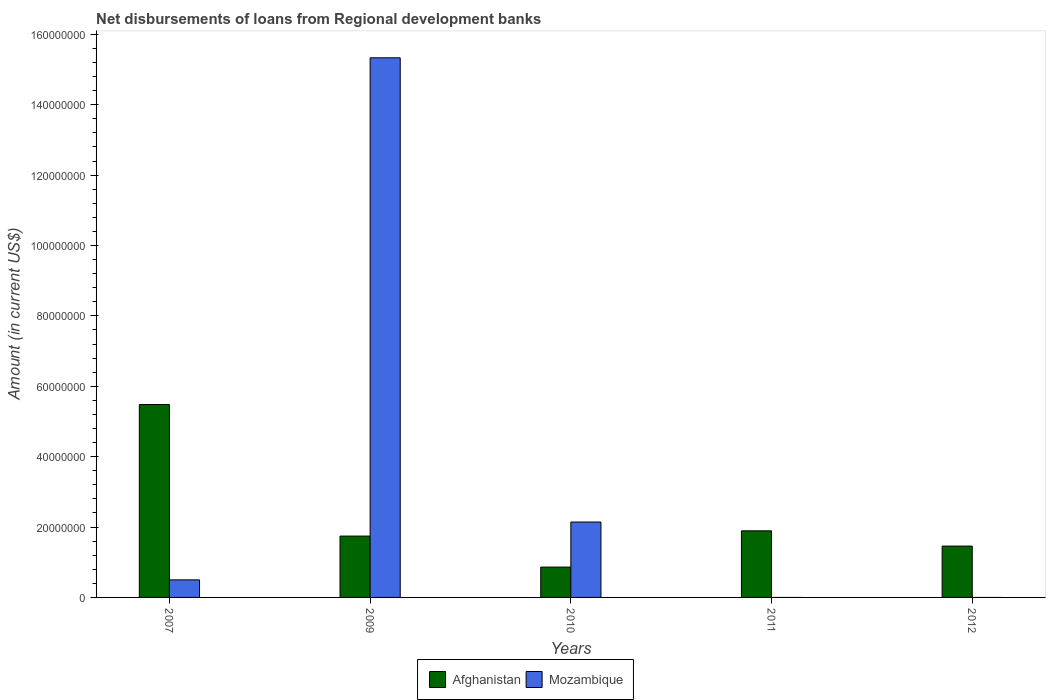How many bars are there on the 3rd tick from the left?
Provide a succinct answer. 2. In how many cases, is the number of bars for a given year not equal to the number of legend labels?
Your response must be concise. 2. What is the amount of disbursements of loans from regional development banks in Mozambique in 2010?
Provide a short and direct response. 2.14e+07. Across all years, what is the maximum amount of disbursements of loans from regional development banks in Mozambique?
Give a very brief answer. 1.53e+08. Across all years, what is the minimum amount of disbursements of loans from regional development banks in Afghanistan?
Keep it short and to the point. 8.62e+06. What is the total amount of disbursements of loans from regional development banks in Mozambique in the graph?
Ensure brevity in your answer.  1.80e+08. What is the difference between the amount of disbursements of loans from regional development banks in Afghanistan in 2007 and that in 2012?
Provide a short and direct response. 4.02e+07. What is the difference between the amount of disbursements of loans from regional development banks in Mozambique in 2011 and the amount of disbursements of loans from regional development banks in Afghanistan in 2012?
Offer a terse response. -1.46e+07. What is the average amount of disbursements of loans from regional development banks in Mozambique per year?
Ensure brevity in your answer.  3.59e+07. In the year 2009, what is the difference between the amount of disbursements of loans from regional development banks in Afghanistan and amount of disbursements of loans from regional development banks in Mozambique?
Offer a terse response. -1.36e+08. In how many years, is the amount of disbursements of loans from regional development banks in Afghanistan greater than 144000000 US$?
Your response must be concise. 0. What is the ratio of the amount of disbursements of loans from regional development banks in Mozambique in 2007 to that in 2010?
Offer a very short reply. 0.23. Is the amount of disbursements of loans from regional development banks in Afghanistan in 2007 less than that in 2011?
Offer a terse response. No. What is the difference between the highest and the second highest amount of disbursements of loans from regional development banks in Afghanistan?
Keep it short and to the point. 3.59e+07. What is the difference between the highest and the lowest amount of disbursements of loans from regional development banks in Afghanistan?
Your answer should be very brief. 4.62e+07. In how many years, is the amount of disbursements of loans from regional development banks in Afghanistan greater than the average amount of disbursements of loans from regional development banks in Afghanistan taken over all years?
Provide a succinct answer. 1. Are all the bars in the graph horizontal?
Your answer should be compact. No. What is the difference between two consecutive major ticks on the Y-axis?
Your answer should be very brief. 2.00e+07. Are the values on the major ticks of Y-axis written in scientific E-notation?
Your answer should be very brief. No. Does the graph contain any zero values?
Offer a very short reply. Yes. Does the graph contain grids?
Provide a succinct answer. No. Where does the legend appear in the graph?
Provide a short and direct response. Bottom center. How many legend labels are there?
Ensure brevity in your answer.  2. How are the legend labels stacked?
Ensure brevity in your answer.  Horizontal. What is the title of the graph?
Provide a succinct answer. Net disbursements of loans from Regional development banks. What is the label or title of the Y-axis?
Your answer should be compact. Amount (in current US$). What is the Amount (in current US$) of Afghanistan in 2007?
Provide a short and direct response. 5.48e+07. What is the Amount (in current US$) of Mozambique in 2007?
Provide a succinct answer. 4.99e+06. What is the Amount (in current US$) of Afghanistan in 2009?
Offer a terse response. 1.74e+07. What is the Amount (in current US$) in Mozambique in 2009?
Provide a short and direct response. 1.53e+08. What is the Amount (in current US$) in Afghanistan in 2010?
Your response must be concise. 8.62e+06. What is the Amount (in current US$) of Mozambique in 2010?
Your answer should be compact. 2.14e+07. What is the Amount (in current US$) of Afghanistan in 2011?
Give a very brief answer. 1.89e+07. What is the Amount (in current US$) of Mozambique in 2011?
Ensure brevity in your answer.  0. What is the Amount (in current US$) in Afghanistan in 2012?
Provide a short and direct response. 1.46e+07. Across all years, what is the maximum Amount (in current US$) of Afghanistan?
Your answer should be compact. 5.48e+07. Across all years, what is the maximum Amount (in current US$) of Mozambique?
Offer a very short reply. 1.53e+08. Across all years, what is the minimum Amount (in current US$) of Afghanistan?
Make the answer very short. 8.62e+06. What is the total Amount (in current US$) of Afghanistan in the graph?
Your answer should be compact. 1.14e+08. What is the total Amount (in current US$) of Mozambique in the graph?
Keep it short and to the point. 1.80e+08. What is the difference between the Amount (in current US$) of Afghanistan in 2007 and that in 2009?
Make the answer very short. 3.74e+07. What is the difference between the Amount (in current US$) of Mozambique in 2007 and that in 2009?
Offer a very short reply. -1.48e+08. What is the difference between the Amount (in current US$) in Afghanistan in 2007 and that in 2010?
Keep it short and to the point. 4.62e+07. What is the difference between the Amount (in current US$) of Mozambique in 2007 and that in 2010?
Your response must be concise. -1.64e+07. What is the difference between the Amount (in current US$) in Afghanistan in 2007 and that in 2011?
Offer a very short reply. 3.59e+07. What is the difference between the Amount (in current US$) of Afghanistan in 2007 and that in 2012?
Offer a very short reply. 4.02e+07. What is the difference between the Amount (in current US$) in Afghanistan in 2009 and that in 2010?
Offer a terse response. 8.81e+06. What is the difference between the Amount (in current US$) in Mozambique in 2009 and that in 2010?
Ensure brevity in your answer.  1.32e+08. What is the difference between the Amount (in current US$) in Afghanistan in 2009 and that in 2011?
Your answer should be very brief. -1.49e+06. What is the difference between the Amount (in current US$) of Afghanistan in 2009 and that in 2012?
Offer a terse response. 2.84e+06. What is the difference between the Amount (in current US$) of Afghanistan in 2010 and that in 2011?
Provide a succinct answer. -1.03e+07. What is the difference between the Amount (in current US$) of Afghanistan in 2010 and that in 2012?
Your answer should be compact. -5.97e+06. What is the difference between the Amount (in current US$) in Afghanistan in 2011 and that in 2012?
Offer a terse response. 4.33e+06. What is the difference between the Amount (in current US$) of Afghanistan in 2007 and the Amount (in current US$) of Mozambique in 2009?
Provide a short and direct response. -9.85e+07. What is the difference between the Amount (in current US$) in Afghanistan in 2007 and the Amount (in current US$) in Mozambique in 2010?
Offer a very short reply. 3.34e+07. What is the difference between the Amount (in current US$) in Afghanistan in 2009 and the Amount (in current US$) in Mozambique in 2010?
Offer a very short reply. -3.99e+06. What is the average Amount (in current US$) in Afghanistan per year?
Provide a succinct answer. 2.29e+07. What is the average Amount (in current US$) in Mozambique per year?
Ensure brevity in your answer.  3.59e+07. In the year 2007, what is the difference between the Amount (in current US$) of Afghanistan and Amount (in current US$) of Mozambique?
Offer a terse response. 4.98e+07. In the year 2009, what is the difference between the Amount (in current US$) of Afghanistan and Amount (in current US$) of Mozambique?
Your answer should be very brief. -1.36e+08. In the year 2010, what is the difference between the Amount (in current US$) in Afghanistan and Amount (in current US$) in Mozambique?
Your answer should be very brief. -1.28e+07. What is the ratio of the Amount (in current US$) in Afghanistan in 2007 to that in 2009?
Make the answer very short. 3.14. What is the ratio of the Amount (in current US$) in Mozambique in 2007 to that in 2009?
Give a very brief answer. 0.03. What is the ratio of the Amount (in current US$) in Afghanistan in 2007 to that in 2010?
Offer a terse response. 6.36. What is the ratio of the Amount (in current US$) in Mozambique in 2007 to that in 2010?
Make the answer very short. 0.23. What is the ratio of the Amount (in current US$) of Afghanistan in 2007 to that in 2011?
Ensure brevity in your answer.  2.9. What is the ratio of the Amount (in current US$) of Afghanistan in 2007 to that in 2012?
Your response must be concise. 3.76. What is the ratio of the Amount (in current US$) in Afghanistan in 2009 to that in 2010?
Keep it short and to the point. 2.02. What is the ratio of the Amount (in current US$) of Mozambique in 2009 to that in 2010?
Offer a very short reply. 7.16. What is the ratio of the Amount (in current US$) in Afghanistan in 2009 to that in 2011?
Your answer should be very brief. 0.92. What is the ratio of the Amount (in current US$) of Afghanistan in 2009 to that in 2012?
Your response must be concise. 1.19. What is the ratio of the Amount (in current US$) of Afghanistan in 2010 to that in 2011?
Offer a very short reply. 0.46. What is the ratio of the Amount (in current US$) of Afghanistan in 2010 to that in 2012?
Your answer should be compact. 0.59. What is the ratio of the Amount (in current US$) in Afghanistan in 2011 to that in 2012?
Offer a terse response. 1.3. What is the difference between the highest and the second highest Amount (in current US$) of Afghanistan?
Provide a succinct answer. 3.59e+07. What is the difference between the highest and the second highest Amount (in current US$) in Mozambique?
Ensure brevity in your answer.  1.32e+08. What is the difference between the highest and the lowest Amount (in current US$) of Afghanistan?
Make the answer very short. 4.62e+07. What is the difference between the highest and the lowest Amount (in current US$) of Mozambique?
Your answer should be very brief. 1.53e+08. 